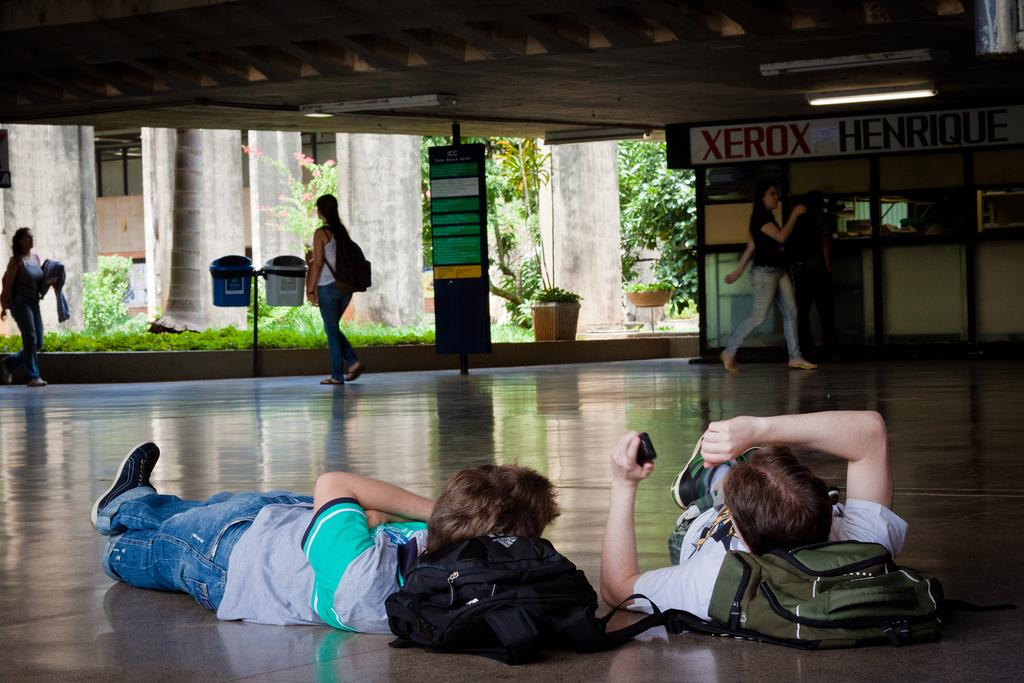Provide a one-sentence caption for the provided image. Two kids lie on the floor as people walk past a Xerox office. 